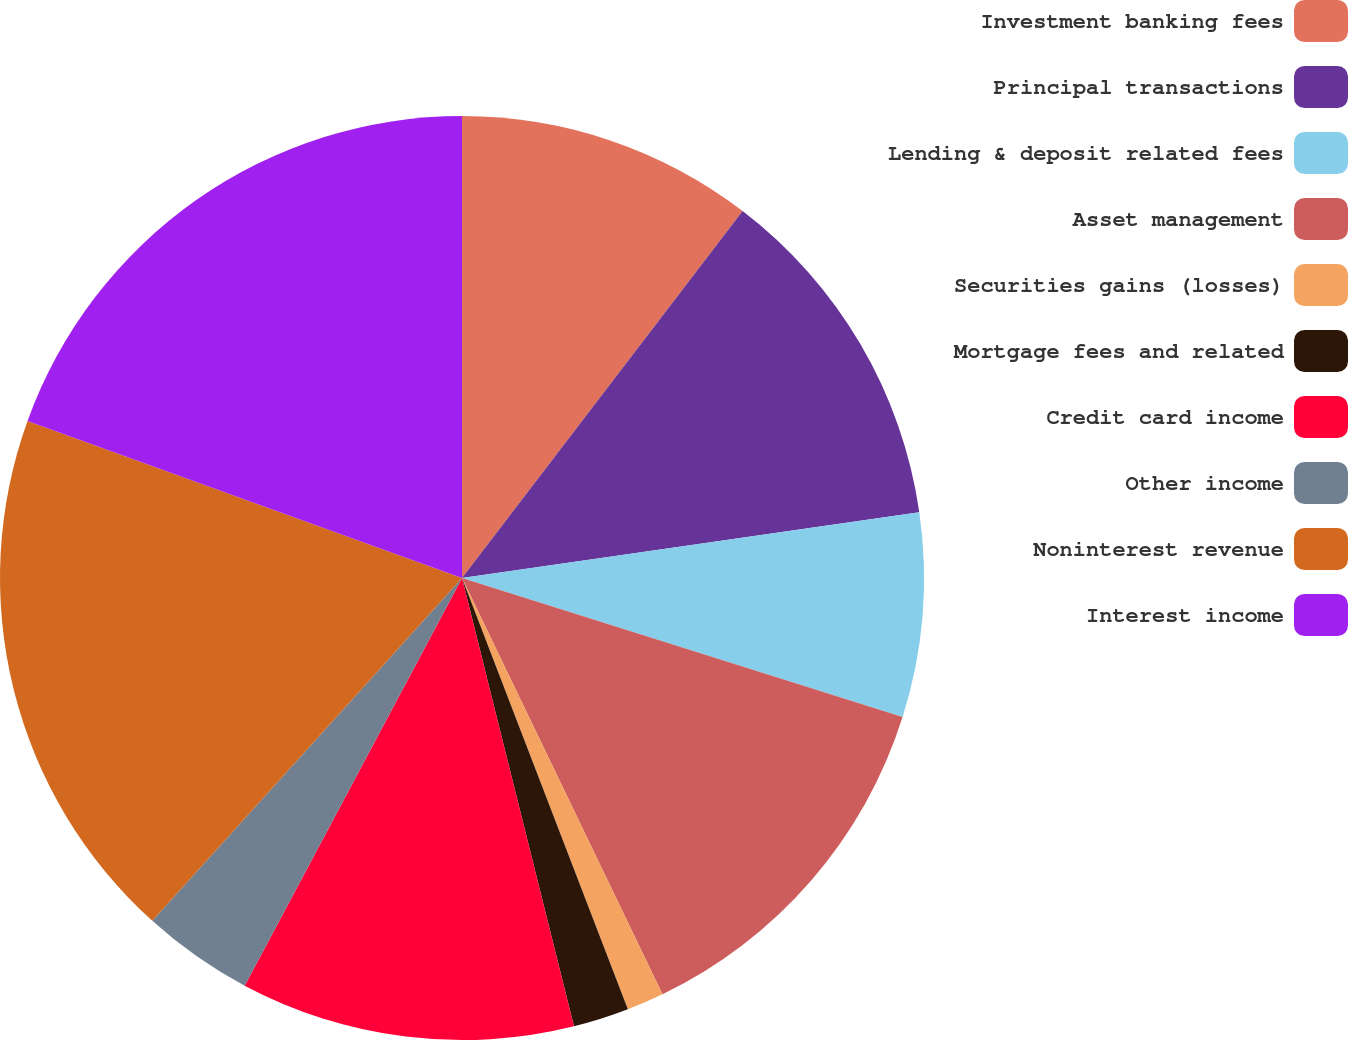Convert chart to OTSL. <chart><loc_0><loc_0><loc_500><loc_500><pie_chart><fcel>Investment banking fees<fcel>Principal transactions<fcel>Lending & deposit related fees<fcel>Asset management<fcel>Securities gains (losses)<fcel>Mortgage fees and related<fcel>Credit card income<fcel>Other income<fcel>Noninterest revenue<fcel>Interest income<nl><fcel>10.39%<fcel>12.34%<fcel>7.14%<fcel>12.99%<fcel>1.3%<fcel>1.95%<fcel>11.69%<fcel>3.9%<fcel>18.83%<fcel>19.48%<nl></chart> 